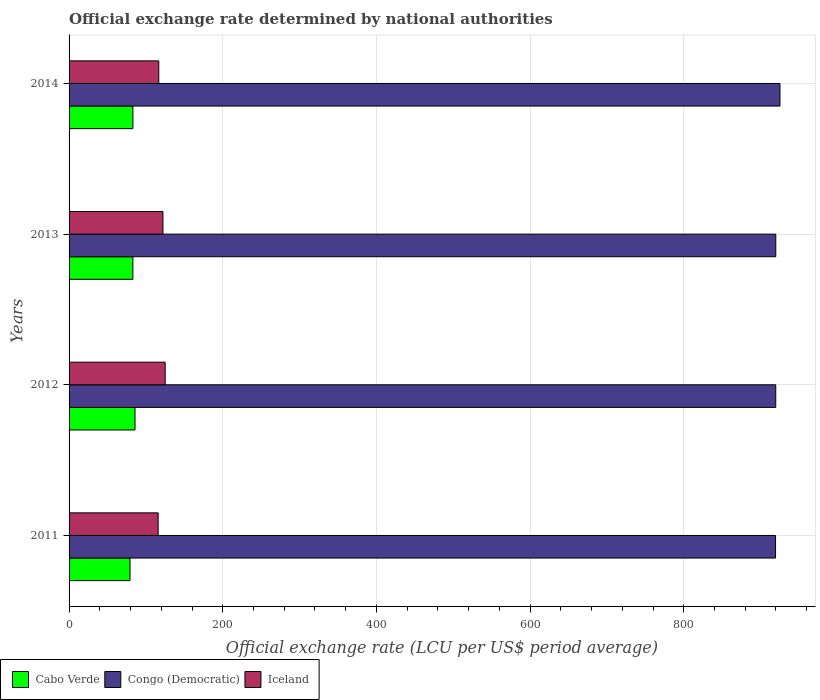How many groups of bars are there?
Provide a short and direct response. 4. Are the number of bars per tick equal to the number of legend labels?
Your answer should be compact. Yes. How many bars are there on the 1st tick from the bottom?
Offer a very short reply. 3. What is the official exchange rate in Congo (Democratic) in 2013?
Make the answer very short. 919.79. Across all years, what is the maximum official exchange rate in Congo (Democratic)?
Offer a terse response. 925.23. Across all years, what is the minimum official exchange rate in Cabo Verde?
Your answer should be compact. 79.32. What is the total official exchange rate in Iceland in the graph?
Give a very brief answer. 479.98. What is the difference between the official exchange rate in Cabo Verde in 2011 and that in 2014?
Your answer should be compact. -3.79. What is the difference between the official exchange rate in Cabo Verde in 2013 and the official exchange rate in Iceland in 2012?
Your answer should be very brief. -42.03. What is the average official exchange rate in Congo (Democratic) per year?
Ensure brevity in your answer.  921.07. In the year 2012, what is the difference between the official exchange rate in Iceland and official exchange rate in Congo (Democratic)?
Offer a very short reply. -794.67. What is the ratio of the official exchange rate in Congo (Democratic) in 2012 to that in 2013?
Offer a terse response. 1. Is the difference between the official exchange rate in Iceland in 2011 and 2013 greater than the difference between the official exchange rate in Congo (Democratic) in 2011 and 2013?
Your answer should be compact. No. What is the difference between the highest and the second highest official exchange rate in Iceland?
Give a very brief answer. 2.9. What is the difference between the highest and the lowest official exchange rate in Iceland?
Offer a terse response. 9.13. In how many years, is the official exchange rate in Cabo Verde greater than the average official exchange rate in Cabo Verde taken over all years?
Provide a succinct answer. 3. What does the 3rd bar from the bottom in 2012 represents?
Your response must be concise. Iceland. Are all the bars in the graph horizontal?
Your answer should be very brief. Yes. What is the difference between two consecutive major ticks on the X-axis?
Make the answer very short. 200. Are the values on the major ticks of X-axis written in scientific E-notation?
Keep it short and to the point. No. Does the graph contain any zero values?
Offer a terse response. No. Does the graph contain grids?
Provide a succinct answer. Yes. Where does the legend appear in the graph?
Offer a very short reply. Bottom left. How many legend labels are there?
Ensure brevity in your answer.  3. What is the title of the graph?
Provide a short and direct response. Official exchange rate determined by national authorities. What is the label or title of the X-axis?
Your answer should be compact. Official exchange rate (LCU per US$ period average). What is the label or title of the Y-axis?
Give a very brief answer. Years. What is the Official exchange rate (LCU per US$ period average) in Cabo Verde in 2011?
Your response must be concise. 79.32. What is the Official exchange rate (LCU per US$ period average) of Congo (Democratic) in 2011?
Your response must be concise. 919.49. What is the Official exchange rate (LCU per US$ period average) of Iceland in 2011?
Ensure brevity in your answer.  115.95. What is the Official exchange rate (LCU per US$ period average) of Cabo Verde in 2012?
Offer a terse response. 85.82. What is the Official exchange rate (LCU per US$ period average) of Congo (Democratic) in 2012?
Give a very brief answer. 919.76. What is the Official exchange rate (LCU per US$ period average) in Iceland in 2012?
Offer a terse response. 125.08. What is the Official exchange rate (LCU per US$ period average) in Cabo Verde in 2013?
Provide a short and direct response. 83.05. What is the Official exchange rate (LCU per US$ period average) in Congo (Democratic) in 2013?
Offer a terse response. 919.79. What is the Official exchange rate (LCU per US$ period average) of Iceland in 2013?
Make the answer very short. 122.18. What is the Official exchange rate (LCU per US$ period average) in Cabo Verde in 2014?
Ensure brevity in your answer.  83.11. What is the Official exchange rate (LCU per US$ period average) in Congo (Democratic) in 2014?
Offer a terse response. 925.23. What is the Official exchange rate (LCU per US$ period average) in Iceland in 2014?
Your response must be concise. 116.77. Across all years, what is the maximum Official exchange rate (LCU per US$ period average) of Cabo Verde?
Provide a succinct answer. 85.82. Across all years, what is the maximum Official exchange rate (LCU per US$ period average) in Congo (Democratic)?
Make the answer very short. 925.23. Across all years, what is the maximum Official exchange rate (LCU per US$ period average) in Iceland?
Your answer should be very brief. 125.08. Across all years, what is the minimum Official exchange rate (LCU per US$ period average) of Cabo Verde?
Keep it short and to the point. 79.32. Across all years, what is the minimum Official exchange rate (LCU per US$ period average) of Congo (Democratic)?
Provide a short and direct response. 919.49. Across all years, what is the minimum Official exchange rate (LCU per US$ period average) in Iceland?
Provide a short and direct response. 115.95. What is the total Official exchange rate (LCU per US$ period average) of Cabo Verde in the graph?
Offer a very short reply. 331.31. What is the total Official exchange rate (LCU per US$ period average) in Congo (Democratic) in the graph?
Keep it short and to the point. 3684.27. What is the total Official exchange rate (LCU per US$ period average) of Iceland in the graph?
Your answer should be very brief. 479.98. What is the difference between the Official exchange rate (LCU per US$ period average) in Cabo Verde in 2011 and that in 2012?
Provide a succinct answer. -6.5. What is the difference between the Official exchange rate (LCU per US$ period average) of Congo (Democratic) in 2011 and that in 2012?
Provide a short and direct response. -0.26. What is the difference between the Official exchange rate (LCU per US$ period average) in Iceland in 2011 and that in 2012?
Your answer should be compact. -9.13. What is the difference between the Official exchange rate (LCU per US$ period average) in Cabo Verde in 2011 and that in 2013?
Your response must be concise. -3.73. What is the difference between the Official exchange rate (LCU per US$ period average) in Congo (Democratic) in 2011 and that in 2013?
Provide a short and direct response. -0.3. What is the difference between the Official exchange rate (LCU per US$ period average) in Iceland in 2011 and that in 2013?
Ensure brevity in your answer.  -6.23. What is the difference between the Official exchange rate (LCU per US$ period average) in Cabo Verde in 2011 and that in 2014?
Provide a succinct answer. -3.79. What is the difference between the Official exchange rate (LCU per US$ period average) of Congo (Democratic) in 2011 and that in 2014?
Provide a succinct answer. -5.74. What is the difference between the Official exchange rate (LCU per US$ period average) in Iceland in 2011 and that in 2014?
Provide a short and direct response. -0.81. What is the difference between the Official exchange rate (LCU per US$ period average) of Cabo Verde in 2012 and that in 2013?
Your response must be concise. 2.77. What is the difference between the Official exchange rate (LCU per US$ period average) in Congo (Democratic) in 2012 and that in 2013?
Keep it short and to the point. -0.04. What is the difference between the Official exchange rate (LCU per US$ period average) in Iceland in 2012 and that in 2013?
Provide a short and direct response. 2.9. What is the difference between the Official exchange rate (LCU per US$ period average) in Cabo Verde in 2012 and that in 2014?
Ensure brevity in your answer.  2.71. What is the difference between the Official exchange rate (LCU per US$ period average) of Congo (Democratic) in 2012 and that in 2014?
Your response must be concise. -5.47. What is the difference between the Official exchange rate (LCU per US$ period average) in Iceland in 2012 and that in 2014?
Make the answer very short. 8.32. What is the difference between the Official exchange rate (LCU per US$ period average) of Cabo Verde in 2013 and that in 2014?
Make the answer very short. -0.06. What is the difference between the Official exchange rate (LCU per US$ period average) of Congo (Democratic) in 2013 and that in 2014?
Give a very brief answer. -5.43. What is the difference between the Official exchange rate (LCU per US$ period average) of Iceland in 2013 and that in 2014?
Keep it short and to the point. 5.41. What is the difference between the Official exchange rate (LCU per US$ period average) of Cabo Verde in 2011 and the Official exchange rate (LCU per US$ period average) of Congo (Democratic) in 2012?
Your response must be concise. -840.43. What is the difference between the Official exchange rate (LCU per US$ period average) of Cabo Verde in 2011 and the Official exchange rate (LCU per US$ period average) of Iceland in 2012?
Offer a terse response. -45.76. What is the difference between the Official exchange rate (LCU per US$ period average) in Congo (Democratic) in 2011 and the Official exchange rate (LCU per US$ period average) in Iceland in 2012?
Provide a succinct answer. 794.41. What is the difference between the Official exchange rate (LCU per US$ period average) of Cabo Verde in 2011 and the Official exchange rate (LCU per US$ period average) of Congo (Democratic) in 2013?
Your answer should be compact. -840.47. What is the difference between the Official exchange rate (LCU per US$ period average) of Cabo Verde in 2011 and the Official exchange rate (LCU per US$ period average) of Iceland in 2013?
Your answer should be compact. -42.86. What is the difference between the Official exchange rate (LCU per US$ period average) of Congo (Democratic) in 2011 and the Official exchange rate (LCU per US$ period average) of Iceland in 2013?
Your answer should be compact. 797.31. What is the difference between the Official exchange rate (LCU per US$ period average) of Cabo Verde in 2011 and the Official exchange rate (LCU per US$ period average) of Congo (Democratic) in 2014?
Provide a short and direct response. -845.9. What is the difference between the Official exchange rate (LCU per US$ period average) of Cabo Verde in 2011 and the Official exchange rate (LCU per US$ period average) of Iceland in 2014?
Make the answer very short. -37.44. What is the difference between the Official exchange rate (LCU per US$ period average) of Congo (Democratic) in 2011 and the Official exchange rate (LCU per US$ period average) of Iceland in 2014?
Make the answer very short. 802.72. What is the difference between the Official exchange rate (LCU per US$ period average) in Cabo Verde in 2012 and the Official exchange rate (LCU per US$ period average) in Congo (Democratic) in 2013?
Offer a terse response. -833.97. What is the difference between the Official exchange rate (LCU per US$ period average) in Cabo Verde in 2012 and the Official exchange rate (LCU per US$ period average) in Iceland in 2013?
Ensure brevity in your answer.  -36.36. What is the difference between the Official exchange rate (LCU per US$ period average) in Congo (Democratic) in 2012 and the Official exchange rate (LCU per US$ period average) in Iceland in 2013?
Keep it short and to the point. 797.58. What is the difference between the Official exchange rate (LCU per US$ period average) in Cabo Verde in 2012 and the Official exchange rate (LCU per US$ period average) in Congo (Democratic) in 2014?
Offer a very short reply. -839.4. What is the difference between the Official exchange rate (LCU per US$ period average) of Cabo Verde in 2012 and the Official exchange rate (LCU per US$ period average) of Iceland in 2014?
Your response must be concise. -30.94. What is the difference between the Official exchange rate (LCU per US$ period average) in Congo (Democratic) in 2012 and the Official exchange rate (LCU per US$ period average) in Iceland in 2014?
Give a very brief answer. 802.99. What is the difference between the Official exchange rate (LCU per US$ period average) of Cabo Verde in 2013 and the Official exchange rate (LCU per US$ period average) of Congo (Democratic) in 2014?
Keep it short and to the point. -842.18. What is the difference between the Official exchange rate (LCU per US$ period average) of Cabo Verde in 2013 and the Official exchange rate (LCU per US$ period average) of Iceland in 2014?
Your answer should be compact. -33.72. What is the difference between the Official exchange rate (LCU per US$ period average) of Congo (Democratic) in 2013 and the Official exchange rate (LCU per US$ period average) of Iceland in 2014?
Your answer should be very brief. 803.03. What is the average Official exchange rate (LCU per US$ period average) of Cabo Verde per year?
Provide a succinct answer. 82.83. What is the average Official exchange rate (LCU per US$ period average) in Congo (Democratic) per year?
Your response must be concise. 921.07. What is the average Official exchange rate (LCU per US$ period average) in Iceland per year?
Offer a very short reply. 120. In the year 2011, what is the difference between the Official exchange rate (LCU per US$ period average) of Cabo Verde and Official exchange rate (LCU per US$ period average) of Congo (Democratic)?
Your answer should be very brief. -840.17. In the year 2011, what is the difference between the Official exchange rate (LCU per US$ period average) of Cabo Verde and Official exchange rate (LCU per US$ period average) of Iceland?
Provide a short and direct response. -36.63. In the year 2011, what is the difference between the Official exchange rate (LCU per US$ period average) in Congo (Democratic) and Official exchange rate (LCU per US$ period average) in Iceland?
Ensure brevity in your answer.  803.54. In the year 2012, what is the difference between the Official exchange rate (LCU per US$ period average) in Cabo Verde and Official exchange rate (LCU per US$ period average) in Congo (Democratic)?
Give a very brief answer. -833.93. In the year 2012, what is the difference between the Official exchange rate (LCU per US$ period average) of Cabo Verde and Official exchange rate (LCU per US$ period average) of Iceland?
Your answer should be compact. -39.26. In the year 2012, what is the difference between the Official exchange rate (LCU per US$ period average) of Congo (Democratic) and Official exchange rate (LCU per US$ period average) of Iceland?
Your answer should be very brief. 794.67. In the year 2013, what is the difference between the Official exchange rate (LCU per US$ period average) in Cabo Verde and Official exchange rate (LCU per US$ period average) in Congo (Democratic)?
Offer a very short reply. -836.74. In the year 2013, what is the difference between the Official exchange rate (LCU per US$ period average) of Cabo Verde and Official exchange rate (LCU per US$ period average) of Iceland?
Ensure brevity in your answer.  -39.13. In the year 2013, what is the difference between the Official exchange rate (LCU per US$ period average) in Congo (Democratic) and Official exchange rate (LCU per US$ period average) in Iceland?
Ensure brevity in your answer.  797.61. In the year 2014, what is the difference between the Official exchange rate (LCU per US$ period average) of Cabo Verde and Official exchange rate (LCU per US$ period average) of Congo (Democratic)?
Your response must be concise. -842.11. In the year 2014, what is the difference between the Official exchange rate (LCU per US$ period average) in Cabo Verde and Official exchange rate (LCU per US$ period average) in Iceland?
Make the answer very short. -33.65. In the year 2014, what is the difference between the Official exchange rate (LCU per US$ period average) in Congo (Democratic) and Official exchange rate (LCU per US$ period average) in Iceland?
Give a very brief answer. 808.46. What is the ratio of the Official exchange rate (LCU per US$ period average) of Cabo Verde in 2011 to that in 2012?
Make the answer very short. 0.92. What is the ratio of the Official exchange rate (LCU per US$ period average) in Iceland in 2011 to that in 2012?
Keep it short and to the point. 0.93. What is the ratio of the Official exchange rate (LCU per US$ period average) in Cabo Verde in 2011 to that in 2013?
Give a very brief answer. 0.96. What is the ratio of the Official exchange rate (LCU per US$ period average) of Iceland in 2011 to that in 2013?
Keep it short and to the point. 0.95. What is the ratio of the Official exchange rate (LCU per US$ period average) of Cabo Verde in 2011 to that in 2014?
Your response must be concise. 0.95. What is the ratio of the Official exchange rate (LCU per US$ period average) of Cabo Verde in 2012 to that in 2013?
Make the answer very short. 1.03. What is the ratio of the Official exchange rate (LCU per US$ period average) of Congo (Democratic) in 2012 to that in 2013?
Ensure brevity in your answer.  1. What is the ratio of the Official exchange rate (LCU per US$ period average) of Iceland in 2012 to that in 2013?
Offer a very short reply. 1.02. What is the ratio of the Official exchange rate (LCU per US$ period average) of Cabo Verde in 2012 to that in 2014?
Offer a terse response. 1.03. What is the ratio of the Official exchange rate (LCU per US$ period average) in Iceland in 2012 to that in 2014?
Keep it short and to the point. 1.07. What is the ratio of the Official exchange rate (LCU per US$ period average) of Congo (Democratic) in 2013 to that in 2014?
Offer a very short reply. 0.99. What is the ratio of the Official exchange rate (LCU per US$ period average) of Iceland in 2013 to that in 2014?
Your response must be concise. 1.05. What is the difference between the highest and the second highest Official exchange rate (LCU per US$ period average) of Cabo Verde?
Ensure brevity in your answer.  2.71. What is the difference between the highest and the second highest Official exchange rate (LCU per US$ period average) in Congo (Democratic)?
Offer a very short reply. 5.43. What is the difference between the highest and the second highest Official exchange rate (LCU per US$ period average) in Iceland?
Give a very brief answer. 2.9. What is the difference between the highest and the lowest Official exchange rate (LCU per US$ period average) of Cabo Verde?
Provide a succinct answer. 6.5. What is the difference between the highest and the lowest Official exchange rate (LCU per US$ period average) of Congo (Democratic)?
Ensure brevity in your answer.  5.74. What is the difference between the highest and the lowest Official exchange rate (LCU per US$ period average) of Iceland?
Provide a short and direct response. 9.13. 